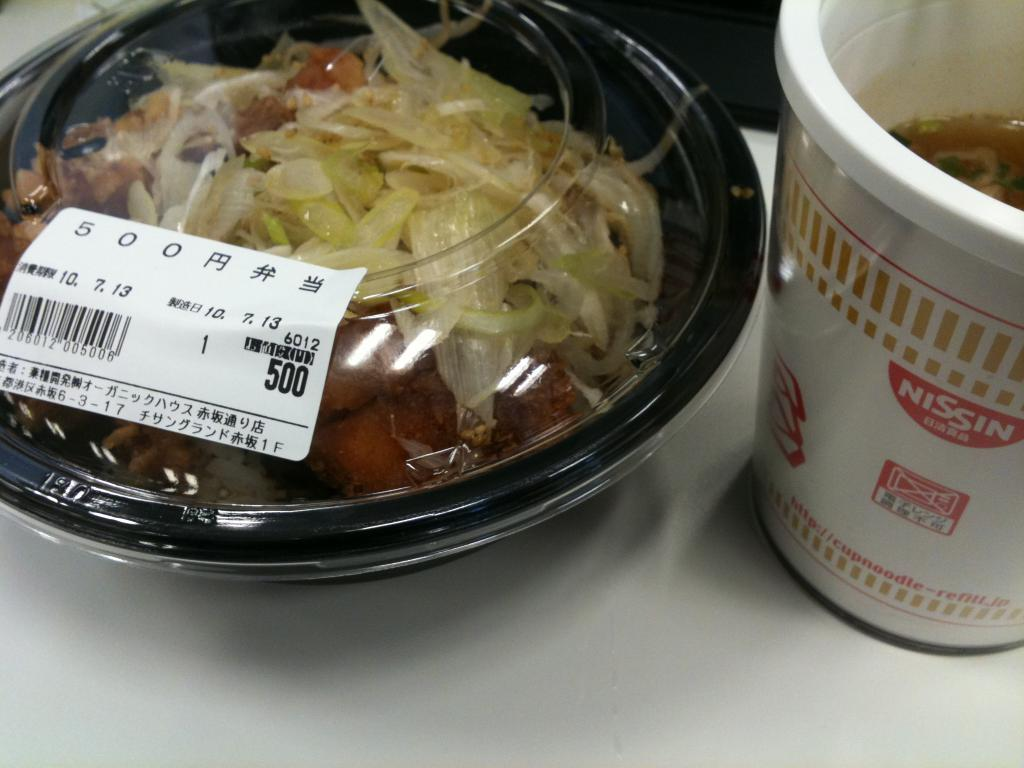What is in the bowl that is visible in the image? There is a food item in the bowl in the image. What other food item can be seen in the image? There is a cup of soup in the image. Where are the bowl and the cup of soup located? Both the bowl and the cup of soup are on a table in the image. What information is provided on the bowl? There is a label with text on the bowl in the image. What type of blade is being used to cut the throat of the system in the image? There is no system, blade, or throat present in the image; it only features a bowl with a food item and a cup of soup on a table. 